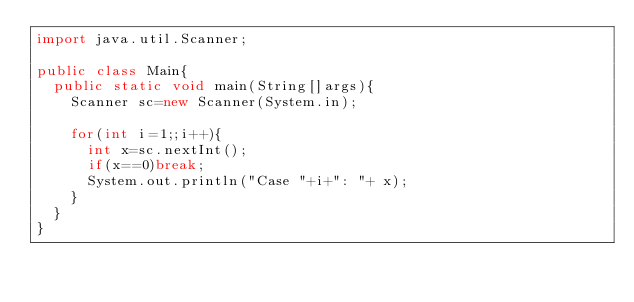<code> <loc_0><loc_0><loc_500><loc_500><_Java_>import java.util.Scanner;

public class Main{
	public static void main(String[]args){
		Scanner sc=new Scanner(System.in);

		for(int i=1;;i++){
			int x=sc.nextInt();
			if(x==0)break;
			System.out.println("Case "+i+": "+ x);
		}
	}
}</code> 